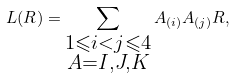Convert formula to latex. <formula><loc_0><loc_0><loc_500><loc_500>L ( R ) = \sum _ { \substack { 1 \leqslant i < j \leqslant 4 \\ A = I , J , K } } A _ { ( i ) } A _ { ( j ) } R ,</formula> 